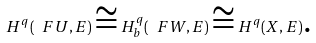<formula> <loc_0><loc_0><loc_500><loc_500>H ^ { q } ( \ F U , E ) \cong H ^ { q } _ { b } ( \ F W , E ) \cong H ^ { q } ( X , E ) \text {.}</formula> 